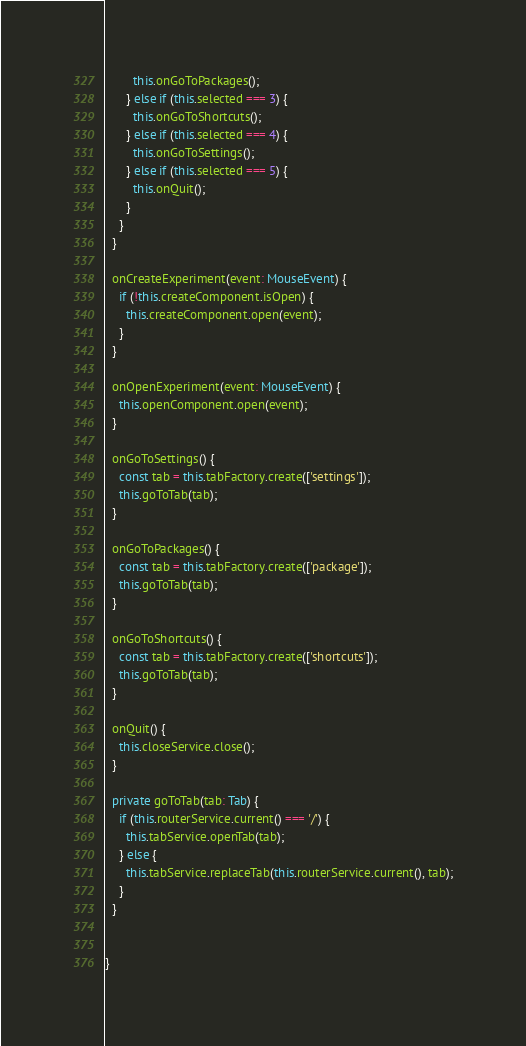<code> <loc_0><loc_0><loc_500><loc_500><_TypeScript_>        this.onGoToPackages();
      } else if (this.selected === 3) {
        this.onGoToShortcuts();
      } else if (this.selected === 4) {
        this.onGoToSettings();
      } else if (this.selected === 5) {
        this.onQuit();
      }
    }
  }

  onCreateExperiment(event: MouseEvent) {
    if (!this.createComponent.isOpen) {
      this.createComponent.open(event);
    }
  }
  
  onOpenExperiment(event: MouseEvent) {
    this.openComponent.open(event);
  }

  onGoToSettings() {
    const tab = this.tabFactory.create(['settings']);
    this.goToTab(tab);
  }

  onGoToPackages() {
    const tab = this.tabFactory.create(['package']);
    this.goToTab(tab);
  }

  onGoToShortcuts() {
    const tab = this.tabFactory.create(['shortcuts']);
    this.goToTab(tab);
  }

  onQuit() {
    this.closeService.close();
  } 
  
  private goToTab(tab: Tab) {
    if (this.routerService.current() === '/') {
      this.tabService.openTab(tab);
    } else {
      this.tabService.replaceTab(this.routerService.current(), tab);
    }
  }


}
</code> 